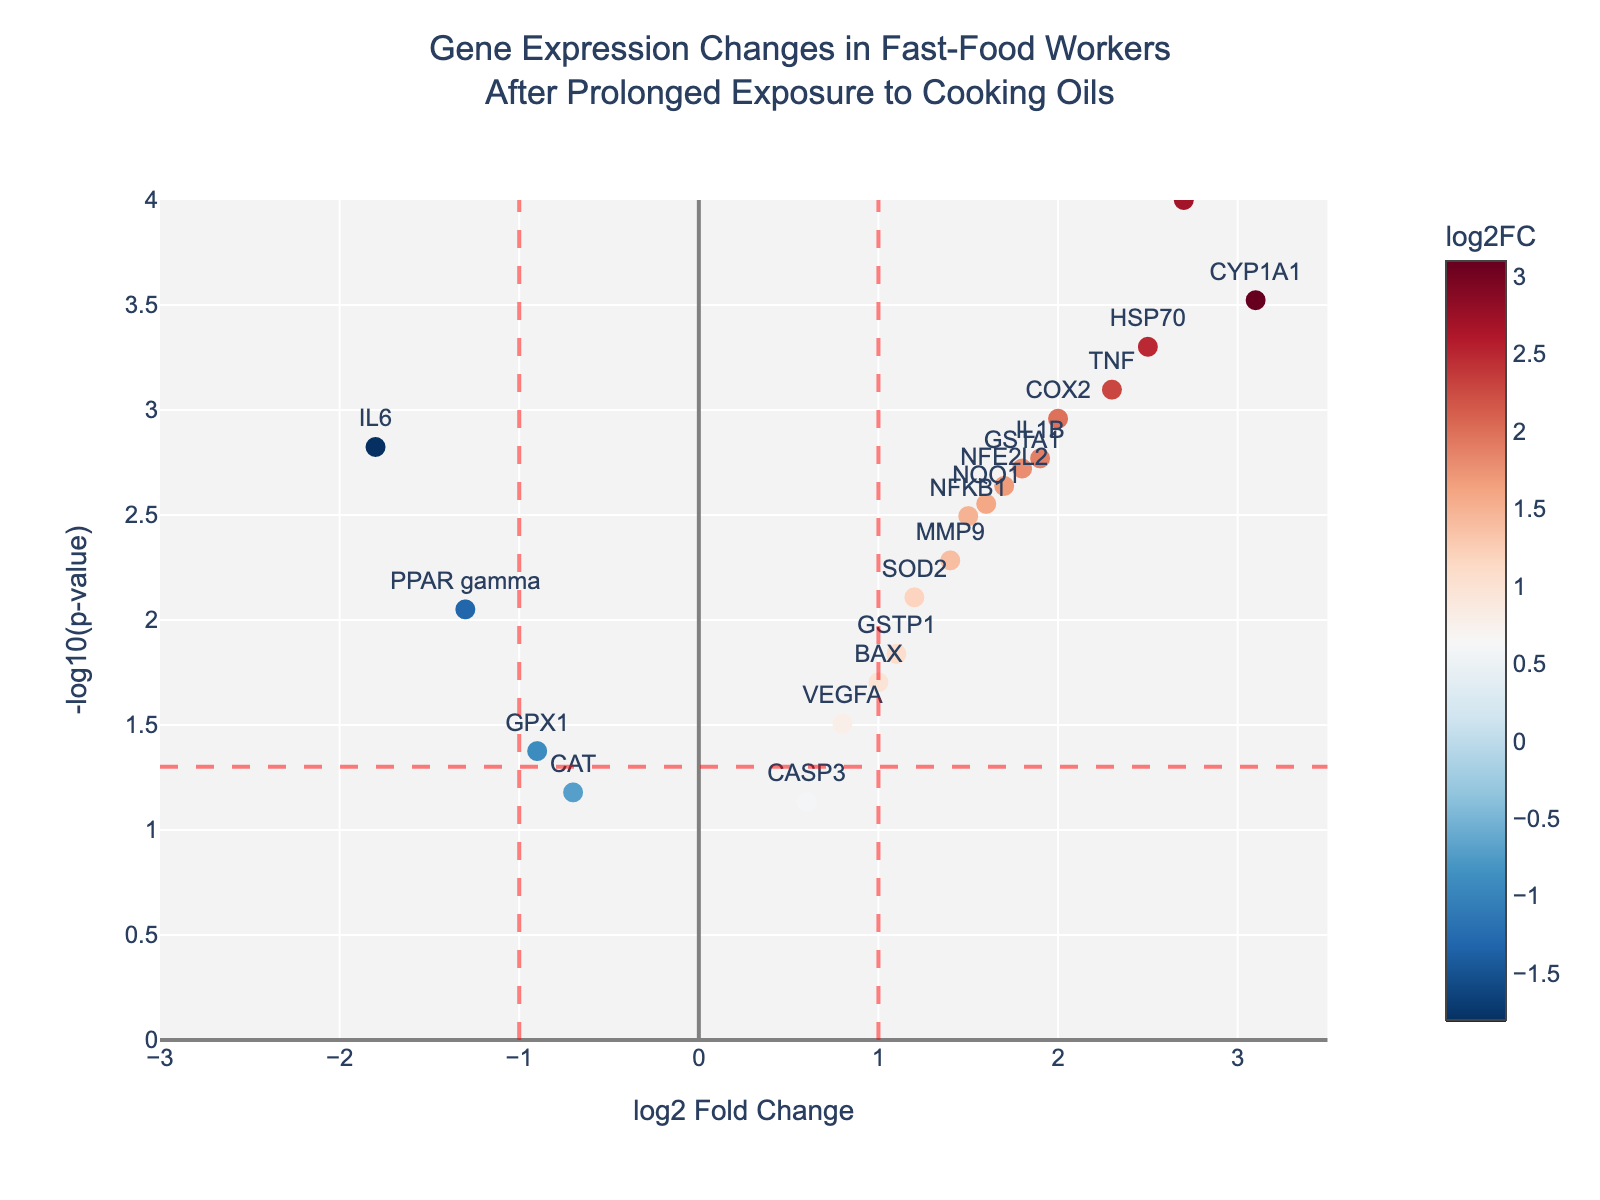What is the title of the figure? The title is located at the top of the figure, and it provides a brief description of the data being presented. It reads, "Gene Expression Changes in Fast-Food Workers After Prolonged Exposure to Cooking Oils."
Answer: Gene Expression Changes in Fast-Food Workers After Prolonged Exposure to Cooking Oils What are the labels of the x-axis and y-axis? The x-axis label is found at the bottom of the graph, and it represents the "log2 Fold Change," indicating the change in gene expression. The y-axis label is on the left side and represents "-log10(p-value)," indicating the statistical significance of the changes.
Answer: log2 Fold Change and -log10(p-value) Which gene has the highest log2 Fold Change? By looking at the genes' positions on the x-axis, the gene with the highest log2 Fold Change is located farthest to the right. From the plot, "CYP1A1" is at the highest position on the x-axis with a value of 3.1.
Answer: CYP1A1 How many genes have a -log10(p-value) greater than 3? To find this, observe the y-axis and count the number of data points above the value of 3. There are three data points meeting this criterion: HMOX1, HSP70, and CYP1A1.
Answer: 3 Which genes are significantly downregulated (log2 Fold Change < -1, p-value < 0.05)? Significant downregulation means looking for genes to the left of x = -1 and above y = -log10(0.05). From the plot, IL6 and PPAR gamma meet these criteria.
Answer: IL6 and PPAR gamma Compare the log2 Fold Change between TNF and COX2. Which one is higher? TNF and COX2's positions on the x-axis indicate their log2 Fold Changes. TNF is at 2.3, and COX2 is at 2.0. Thus, TNF has a higher log2 Fold Change.
Answer: TNF What is the significance threshold applied in the figure, and how is it visually represented? The significance threshold for the p-value is set at 0.05, which corresponds to -log10(0.05) ≈ 1.3. It's visually represented by a red dashed horizontal line across the plot.
Answer: 0.05 (represented by a red dashed line at ≈ 1.3) Which gene has the lowest p-value? The lowest p-value corresponds to the highest position on the y-axis. From the plot, "HMOX1" is at the highest position (with the smallest p-value of 0.0001).
Answer: HMOX1 How many genes have a log2 Fold Change between -1 and 1 and are not considered significant? To find this, count the data points within -1 and 1 on the x-axis that are below the y = -log10(0.05) line. There are 4 genes in this range: GPX1, CAT, VEGFA, and CASP3.
Answer: 4 Which gene has the closest log2 Fold Change to zero but is still considered significant? Look for the gene closest to the y-axis (log2 Fold Change ≈ 0) but above the y = -log10(0.05) red line. "GPX1" has a log2 Fold Change of -0.9 and is significant.
Answer: GPX1 